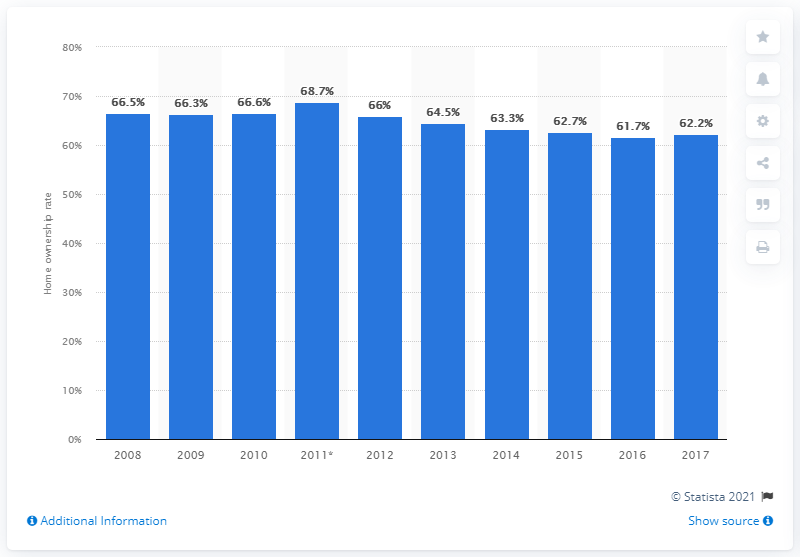Point out several critical features in this image. The home ownership rate in Denmark between 2008 and 2017 was 62.2%. 